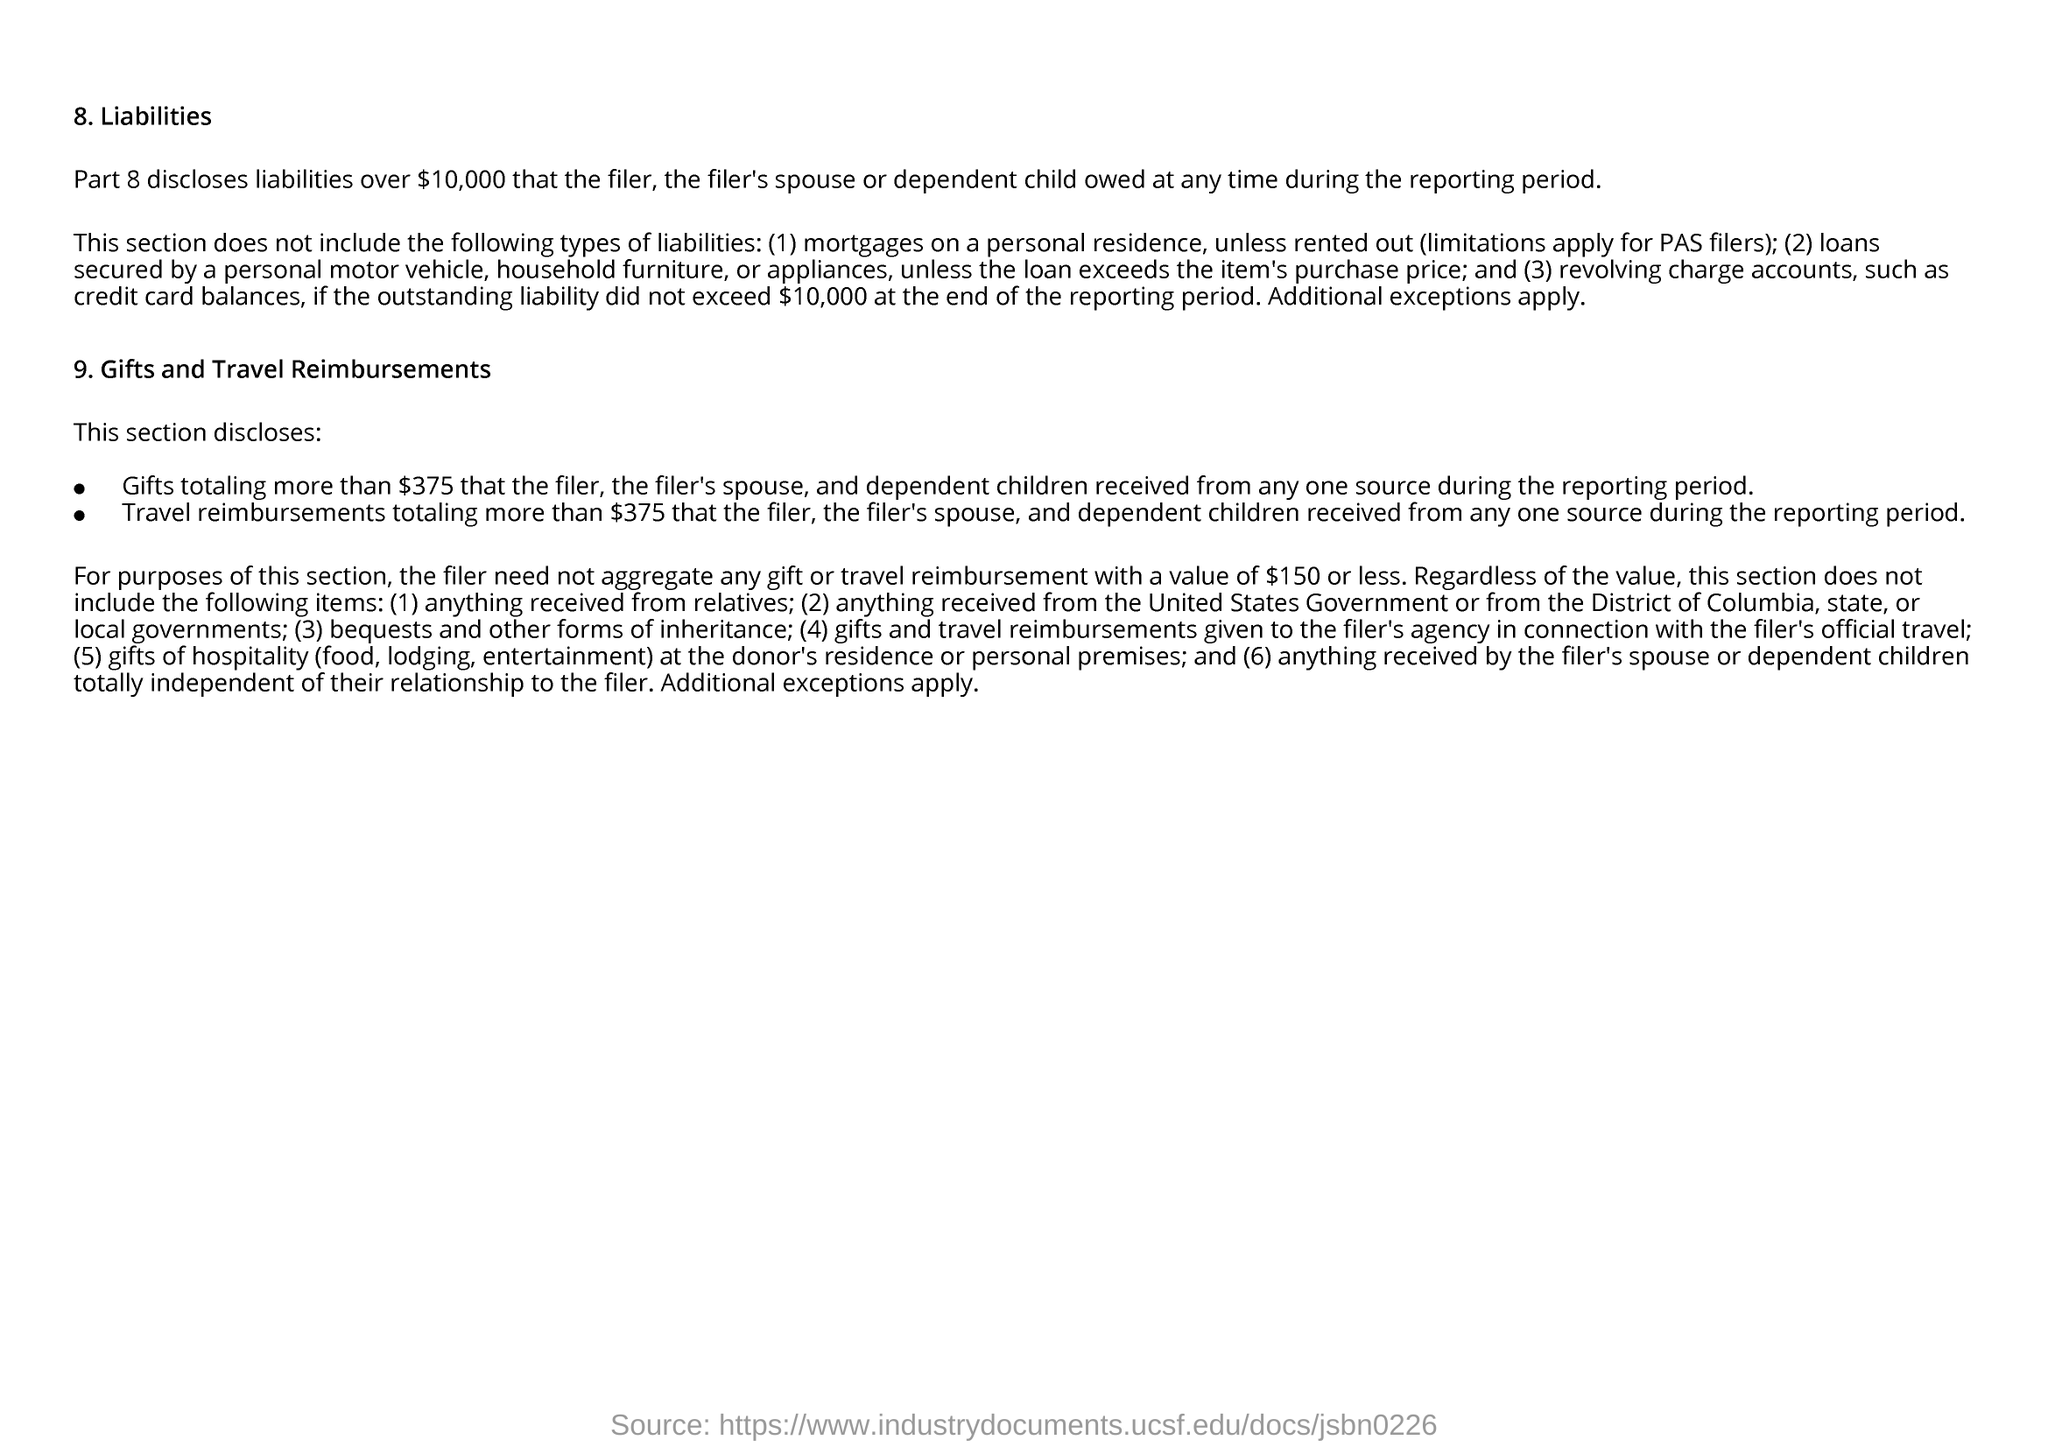What is the first title in the document?
Give a very brief answer. Liabilities. 